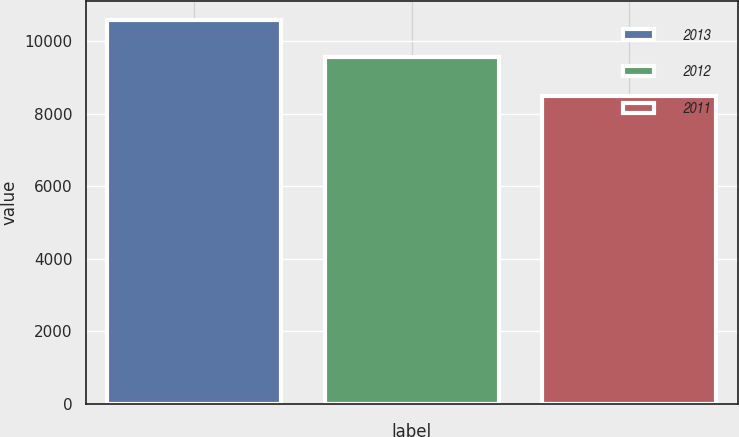<chart> <loc_0><loc_0><loc_500><loc_500><bar_chart><fcel>2013<fcel>2012<fcel>2011<nl><fcel>10578<fcel>9573<fcel>8485<nl></chart> 